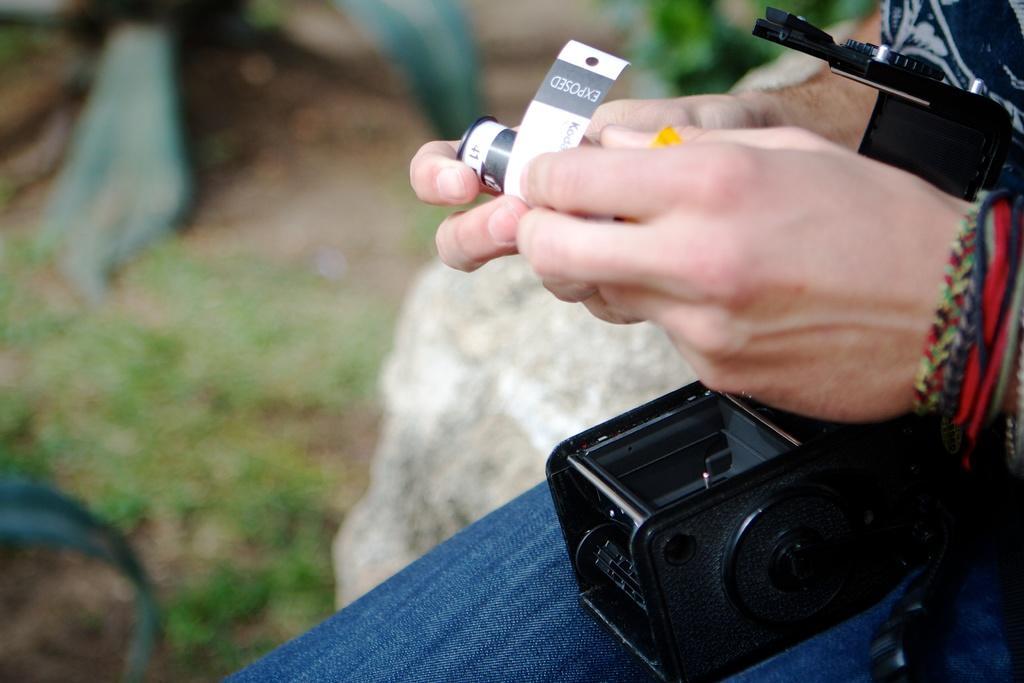Can you describe this image briefly? In this image we can see a person holding a camera film. On the lap of the person there is a camera. In the background it is blur. 